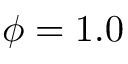<formula> <loc_0><loc_0><loc_500><loc_500>\phi = 1 . 0</formula> 